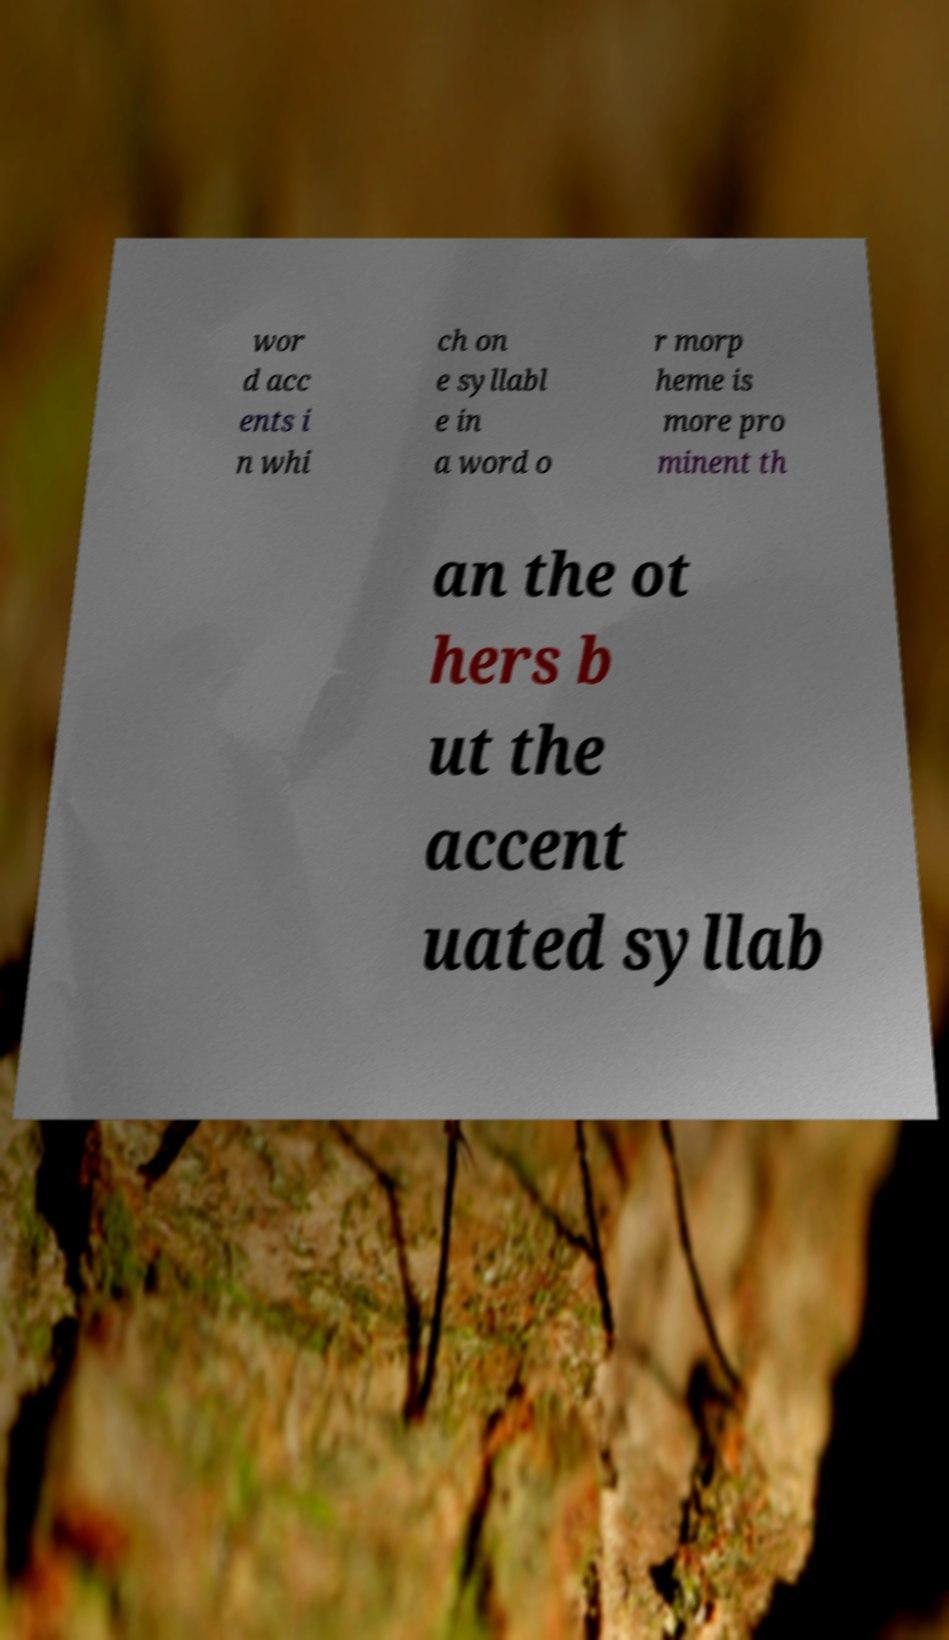Could you extract and type out the text from this image? wor d acc ents i n whi ch on e syllabl e in a word o r morp heme is more pro minent th an the ot hers b ut the accent uated syllab 